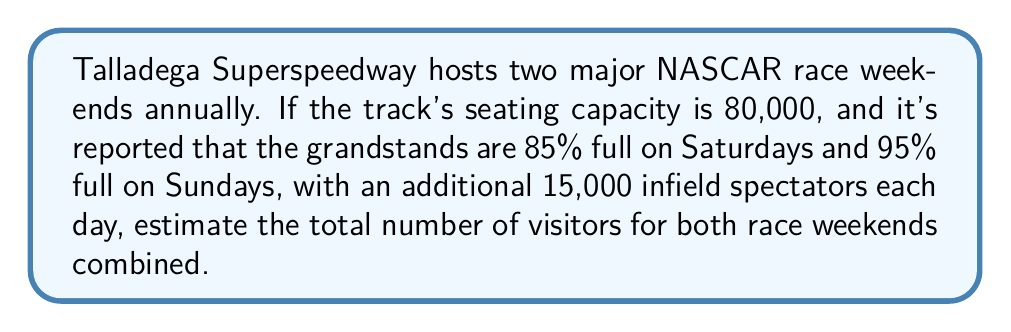Solve this math problem. Let's break this down step-by-step:

1. Calculate the number of spectators in the grandstands on Saturdays:
   $80,000 \times 0.85 = 68,000$

2. Calculate the number of spectators in the grandstands on Sundays:
   $80,000 \times 0.95 = 76,000$

3. Add the infield spectators for each day:
   Saturday: $68,000 + 15,000 = 83,000$
   Sunday: $76,000 + 15,000 = 91,000$

4. Calculate the total for one race weekend:
   $83,000 + 91,000 = 174,000$

5. Since there are two major race weekends annually, multiply by 2:
   $174,000 \times 2 = 348,000$

Therefore, the estimated total number of visitors for both race weekends combined is 348,000.
Answer: 348,000 visitors 